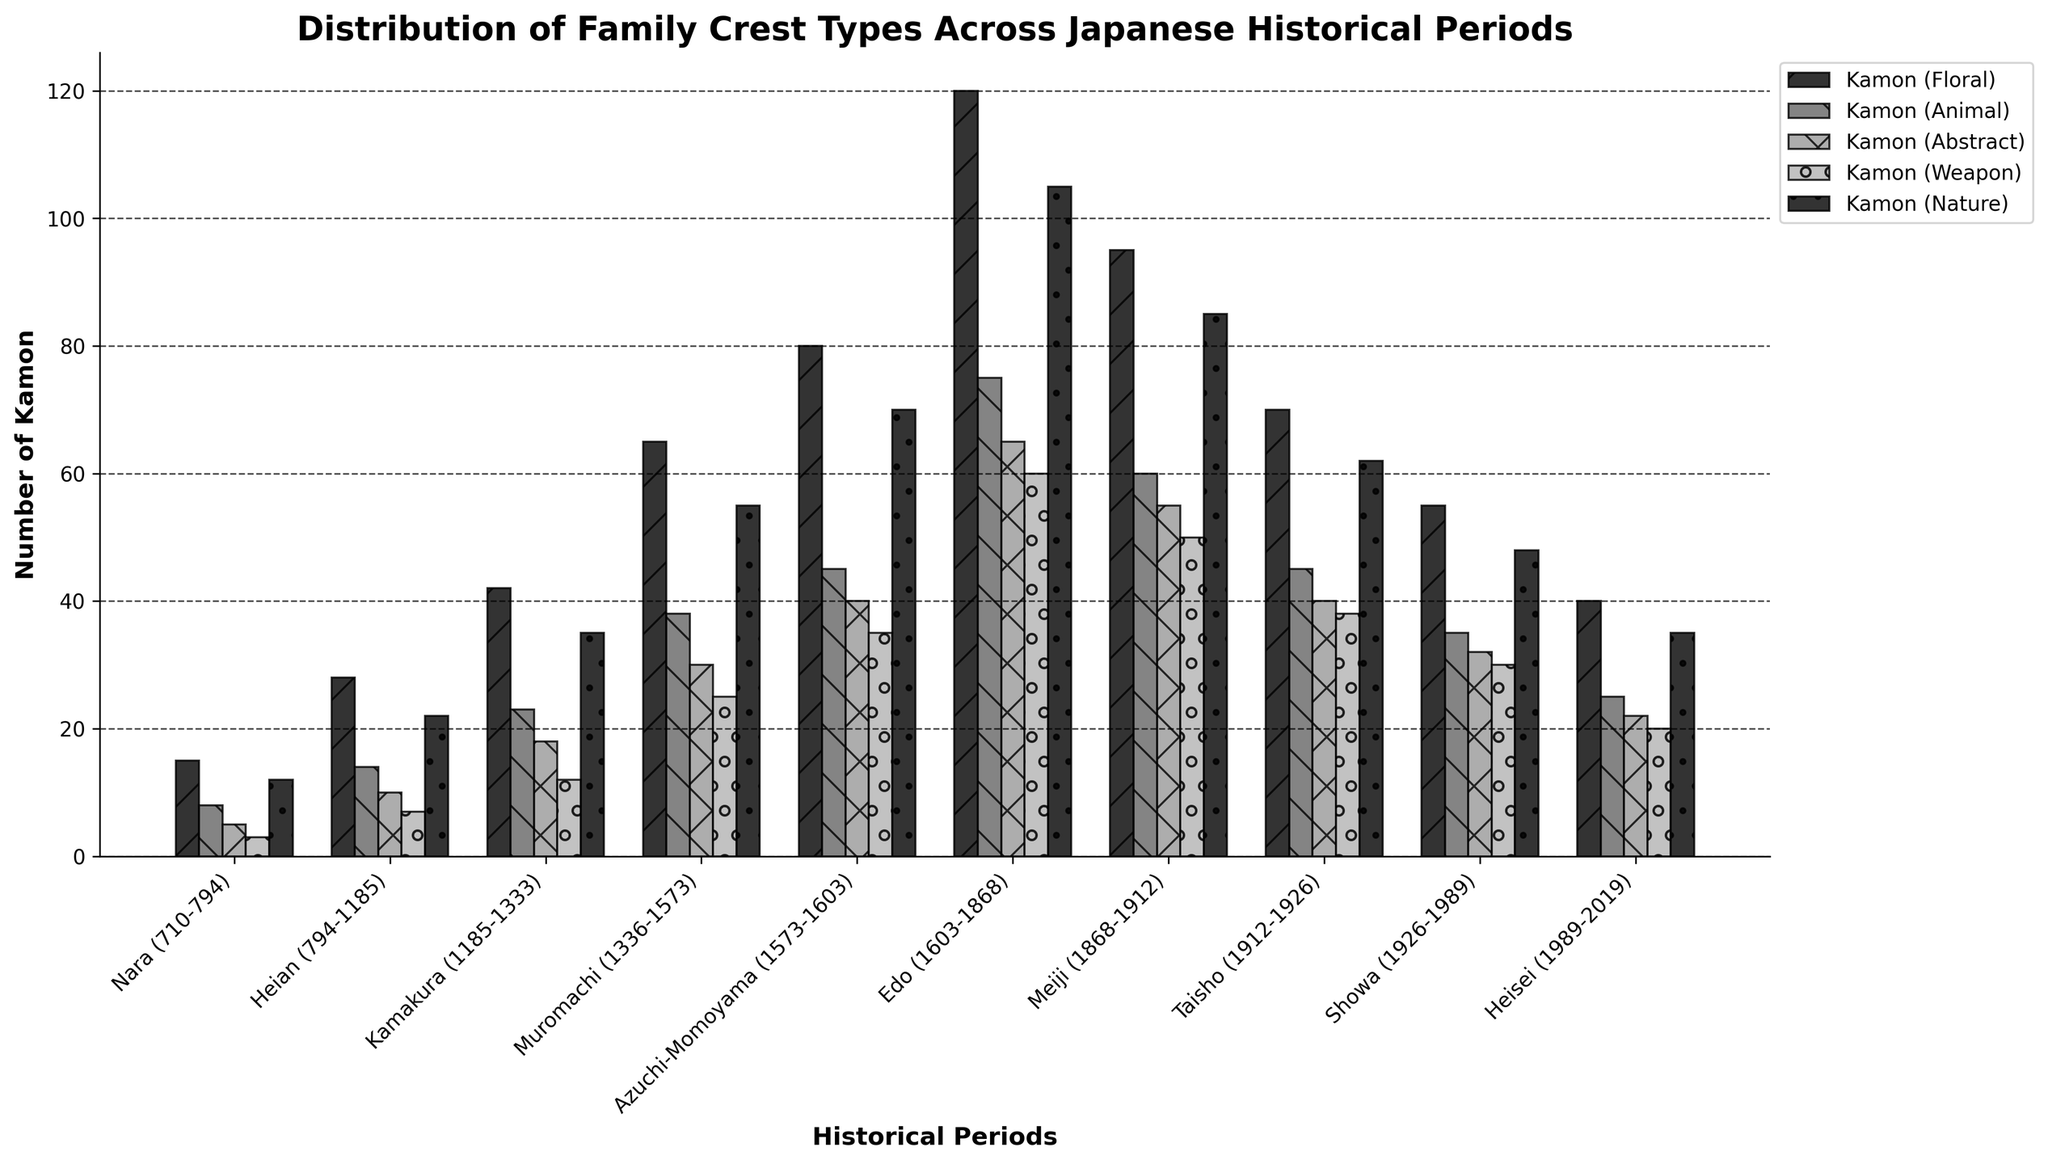Which historical period has the highest number of Kamon (Floral)? The plot shows distinct bars for each Kamon type across different periods. The tallest bar for Kamon (Floral) is during the Edo period (1603-1868).
Answer: Edo (1603-1868) How many more Kamon (Animal) were there in the Edo period compared to the Heian period? Find the height for Kamon (Animal) during the Edo period and the Heian period. Subtract the smaller value from the larger value: 75 (Edo) - 14 (Heian) = 61.
Answer: 61 Which two periods have the same number of Kamon (Weapon)? Compare the heights of the Kamon (Weapon) bars across all periods. The Taisho (1912-1926) and Showa (1926-1989) periods both have 38 Kamon (Weapon).
Answer: Taisho (1912-1926) and Showa (1926-1989) What is the total number of Kamon (Nature) across all periods? Sum the heights of the Kamon (Nature) bars for all periods: 12 + 22 + 35 + 55 + 70 + 105 + 85 + 62 + 48 + 35 = 529.
Answer: 529 In which period was the ratio of Kamon (Abstract) to Kamon (Nature) the highest? Calculate the ratio of Kamon (Abstract) to Kamon (Nature) for each period, then compare: 
- Nara: 5/12 ≈ 0.42
- Heian: 10/22 ≈ 0.45
- Kamakura: 18/35 ≈ 0.51
- Muromachi: 30/55 ≈ 0.55
- Azuchi-Momoyama: 40/70 ≈ 0.57
- Edo: 65/105 ≈ 0.62
- Meiji: 55/85 ≈ 0.65
- Taisho: 40/62 ≈ 0.65
- Showa: 32/48 ≈ 0.67
- Heisei: 22/35 ≈ 0.63
The Showa period has the highest ratio.
Answer: Showa (1926-1989) How does the number of Kamon (Weapon) in the Azuchi-Momoyama period compare to the number in the Kamakura period? Compare the heights of the Kamon (Weapon) bars between these periods: 35 (Azuchi-Momoyama) and 12 (Kamakura), Azuchi-Momoyama has more.
Answer: Azuchi-Momoyama has more What is the difference in the number of Kamon (Nature) between the Heian and Showa periods? Find the height of the Kamon (Nature) bar in both periods and subtract: 48 (Showa) - 22 (Heian) = 26.
Answer: 26 Which period saw the greatest increase in the number of Kamon (Floral) compared to the preceding period? Compute the change in Kamon (Floral) from one period to the next and find the maximum increase:
- Nara to Heian: 28 - 15 = 13
- Heian to Kamakura: 42 - 28 = 14
- Kamakura to Muromachi: 65 - 42 = 23
- Muromachi to Azuchi-Momoyama: 80 - 65 = 15
- Azuchi-Momoyama to Edo: 120 - 80 = 40
- Edo to Meiji: 95 - 120 = -25
- Meiji to Taisho: 70 - 95 = -25
- Taisho to Showa: 55 - 70 = -15
- Showa to Heisei: 40 - 55 = -15
The greatest increase is from Azuchi-Momoyama to Edo.
Answer: Azuchi-Momoyama to Edo 